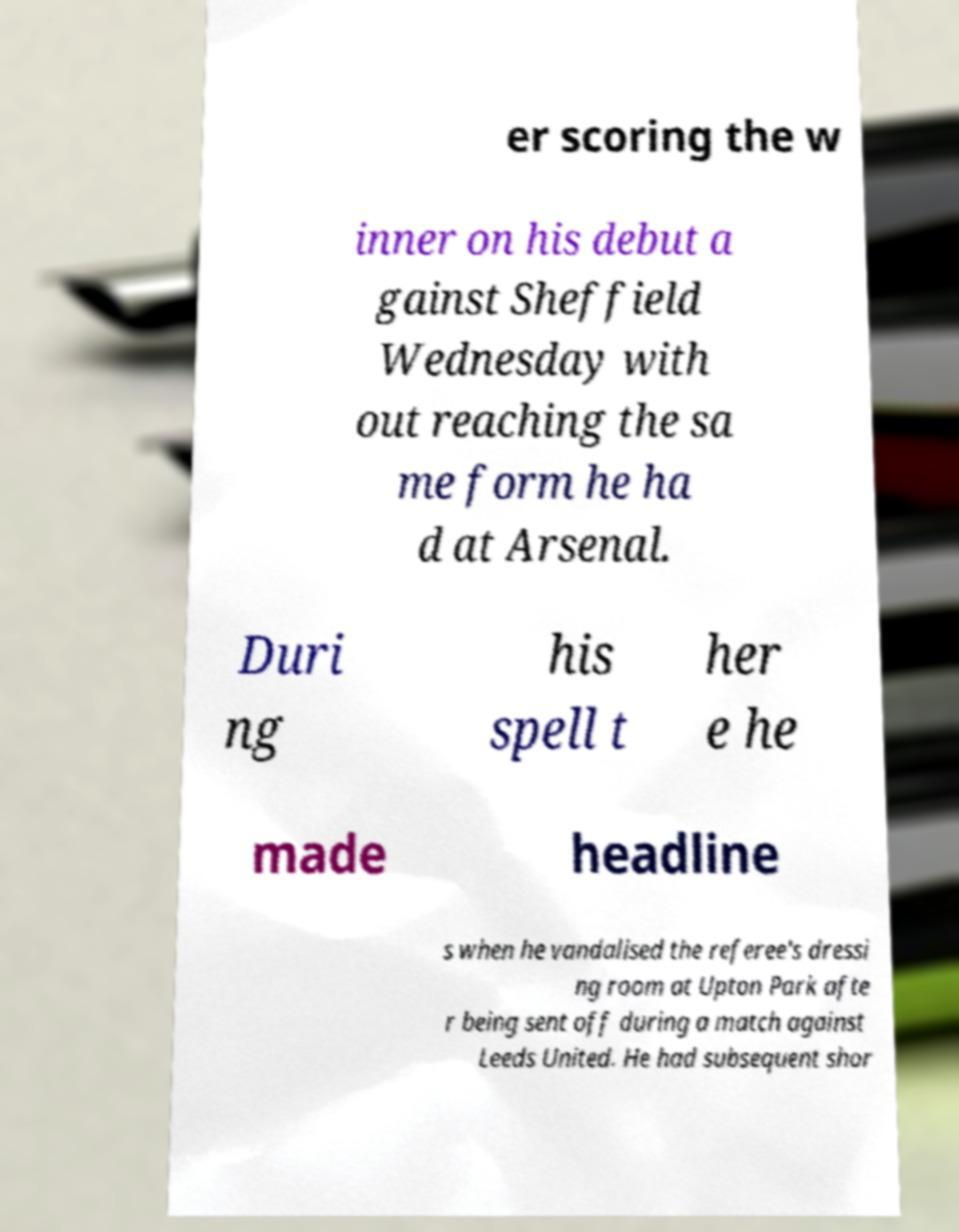For documentation purposes, I need the text within this image transcribed. Could you provide that? er scoring the w inner on his debut a gainst Sheffield Wednesday with out reaching the sa me form he ha d at Arsenal. Duri ng his spell t her e he made headline s when he vandalised the referee's dressi ng room at Upton Park afte r being sent off during a match against Leeds United. He had subsequent shor 